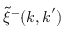Convert formula to latex. <formula><loc_0><loc_0><loc_500><loc_500>\tilde { \xi } ^ { - } ( k , k ^ { \prime } )</formula> 